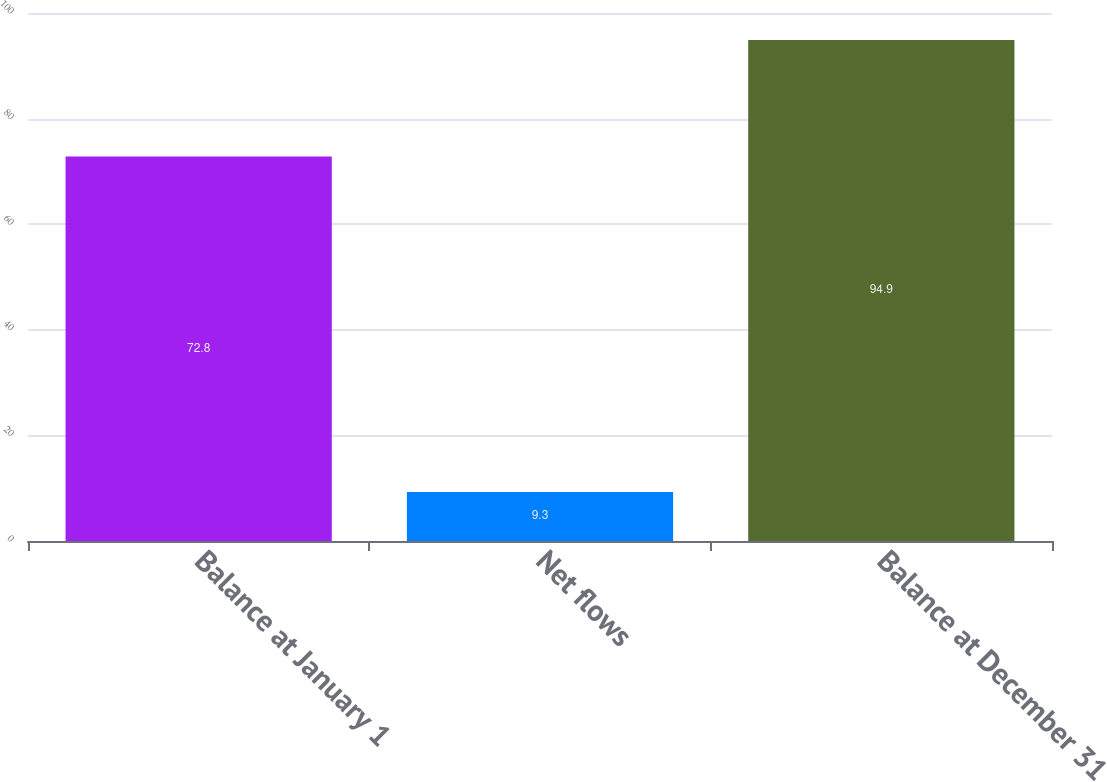Convert chart. <chart><loc_0><loc_0><loc_500><loc_500><bar_chart><fcel>Balance at January 1<fcel>Net flows<fcel>Balance at December 31<nl><fcel>72.8<fcel>9.3<fcel>94.9<nl></chart> 